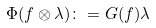Convert formula to latex. <formula><loc_0><loc_0><loc_500><loc_500>\Phi ( f \otimes \lambda ) \colon = G ( f ) \lambda</formula> 